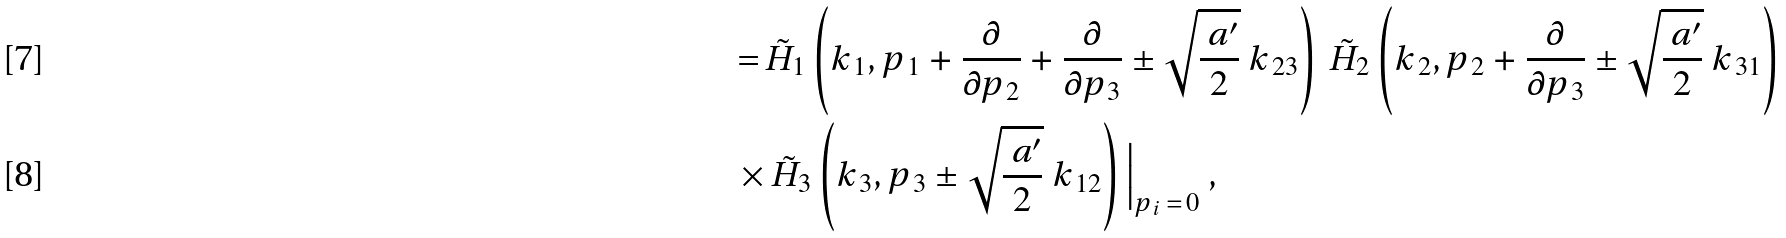<formula> <loc_0><loc_0><loc_500><loc_500>\, = \, & \tilde { H } _ { 1 } \left ( k _ { \, 1 } , p _ { \, 1 } + \frac { \partial } { \partial p _ { \, 2 } } + \frac { \partial } { \partial p _ { \, 3 } } \pm \sqrt { \frac { \ a ^ { \prime } } { 2 } } \ k _ { \, 2 3 } \right ) \, \tilde { H } _ { 2 } \left ( k _ { \, 2 } , p _ { \, 2 } + \frac { \partial } { \partial p _ { \, 3 } } \pm \sqrt { \frac { \ a ^ { \prime } } { 2 } } \ k _ { \, 3 1 } \right ) \\ \times & \, \tilde { H } _ { 3 } \left ( k _ { \, 3 } , p _ { \, 3 } \pm \sqrt { \frac { \ a ^ { \prime } } { 2 } } \ k _ { \, 1 2 } \right ) \Big | _ { p _ { \, i } \, = \, 0 } \ ,</formula> 